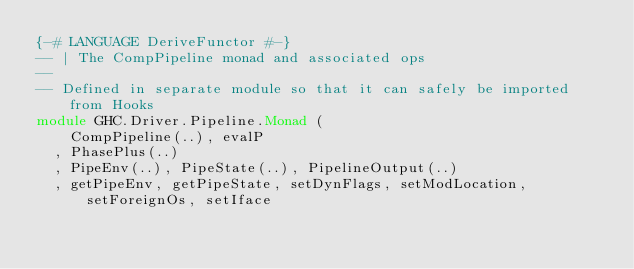Convert code to text. <code><loc_0><loc_0><loc_500><loc_500><_Haskell_>{-# LANGUAGE DeriveFunctor #-}
-- | The CompPipeline monad and associated ops
--
-- Defined in separate module so that it can safely be imported from Hooks
module GHC.Driver.Pipeline.Monad (
    CompPipeline(..), evalP
  , PhasePlus(..)
  , PipeEnv(..), PipeState(..), PipelineOutput(..)
  , getPipeEnv, getPipeState, setDynFlags, setModLocation, setForeignOs, setIface</code> 